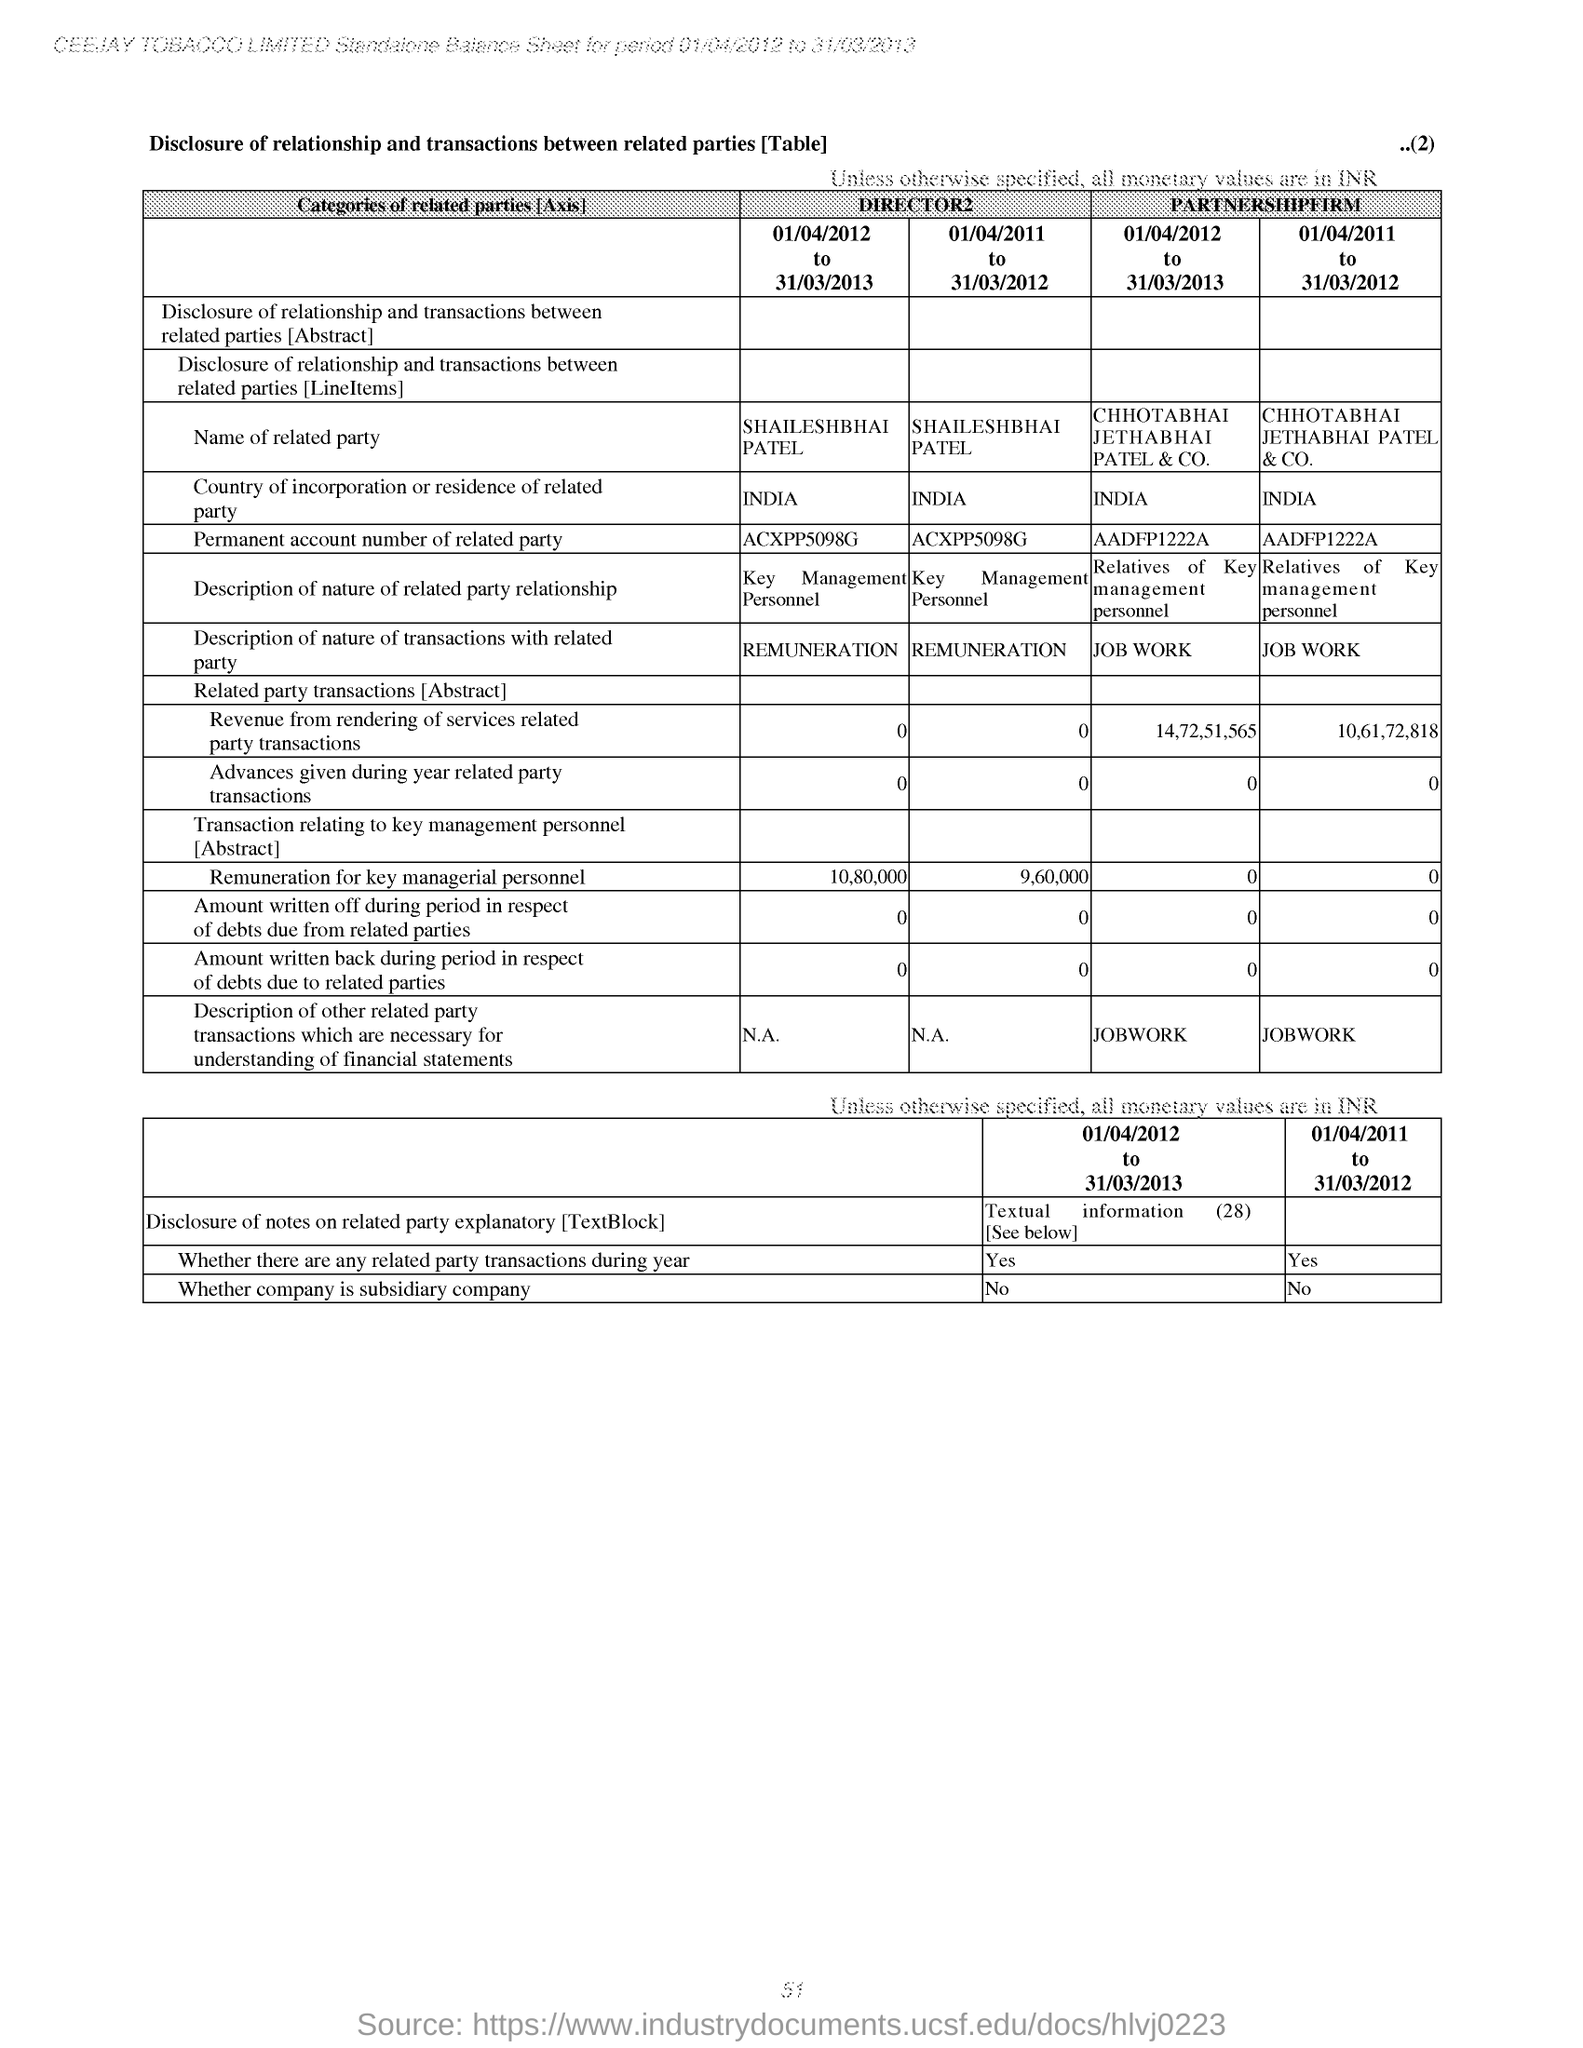Specify some key components in this picture. The company is not a subsidiary company. 